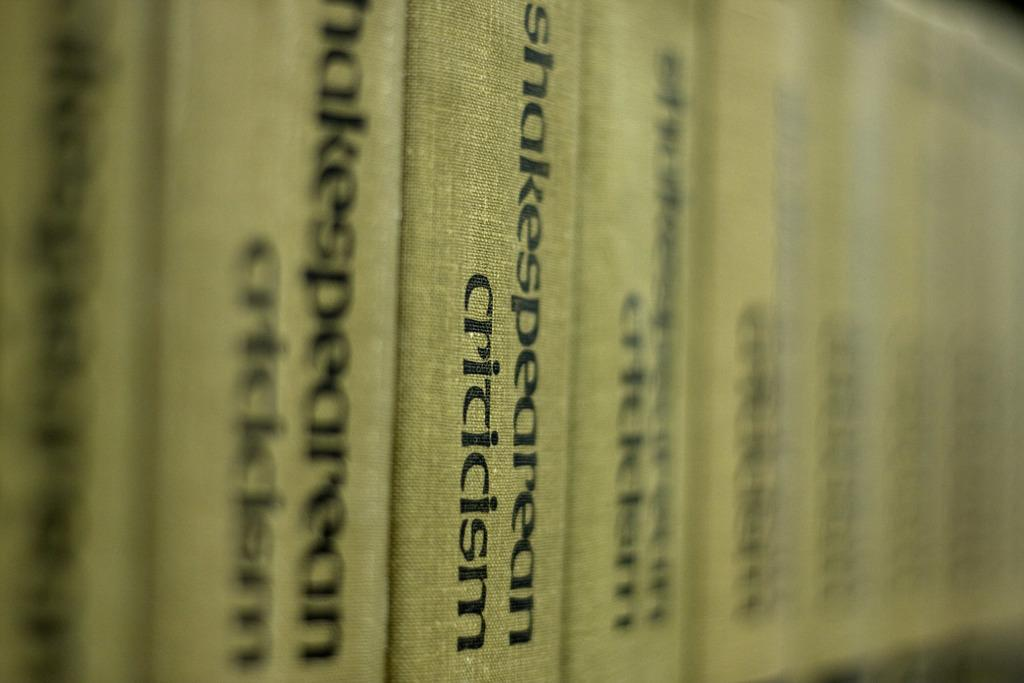<image>
Write a terse but informative summary of the picture. Books in a row that says the word "Criticism" on it. 